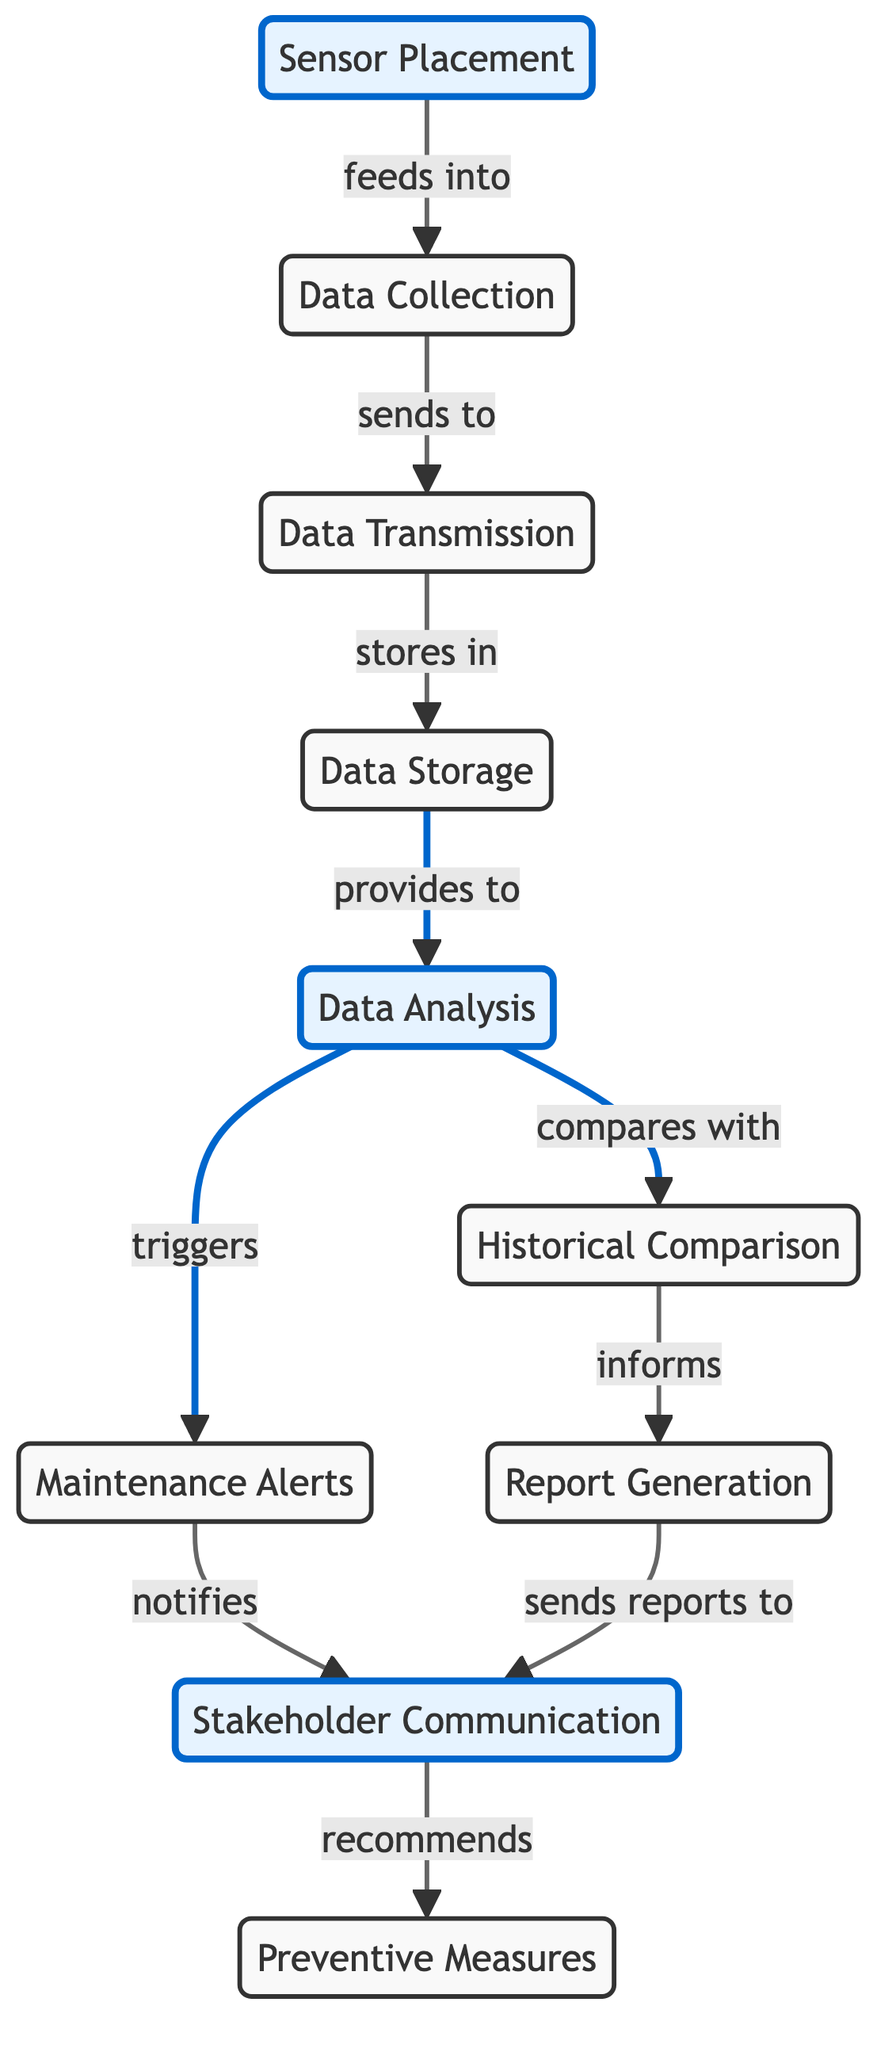What's the number of nodes in the diagram? The diagram lists 10 distinct nodes representing different elements of structural health monitoring.
Answer: 10 What is the relationship between Data Collection and Data Storage? Data Collection sends data to Data Transmission, which then stores the data in Data Storage. This flow indicates a direct connection where Data Transmission acts as an intermediary.
Answer: sends to Which node triggers Maintenance Alerts? The Maintenance Alerts node is triggered by Data Analysis, indicating that issues are identified during the data analysis process.
Answer: Data Analysis What does Stakeholder Communication receive reports from? Stakeholder Communication receives reports from Report Generation, indicating that findings and maintenance needs are communicated based on generated reports.
Answer: Report Generation How many edges are in the diagram? The diagram has 10 edges that represent the connections between nodes, illustrating the flow of information.
Answer: 10 Which two nodes are compared during the analysis? The Data Analysis node compares the current data with Historical Comparison to discern patterns and trends over time.
Answer: Historical Comparison What is the final step recommended after Stakeholder Communication? The final step recommended after Stakeholder Communication is the implementation of Preventive Measures to address potential future structural issues.
Answer: Preventive Measures Which node stores the data collected? Data Storage is the node responsible for storing data that has been collected from sensors.
Answer: Data Storage What informs the Report Generation node? The Report Generation node is informed by Historical Comparison, which provides context for the current data compared to historical data.
Answer: Historical Comparison Which step follows after Maintenance Alerts are triggered? After Maintenance Alerts are triggered, the next step is Stakeholder Communication, which takes action based on the alerts received.
Answer: Stakeholder Communication 